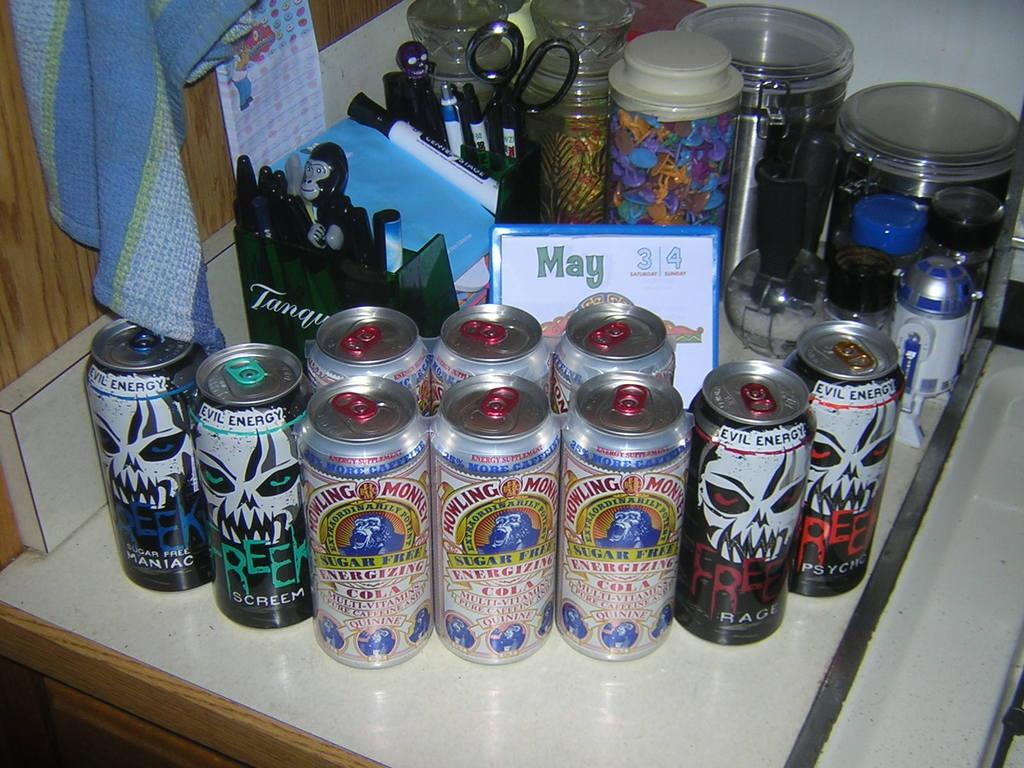<image>
Offer a succinct explanation of the picture presented. Various brands of energy drinks, Howling at the Moon and Maniac for example. 